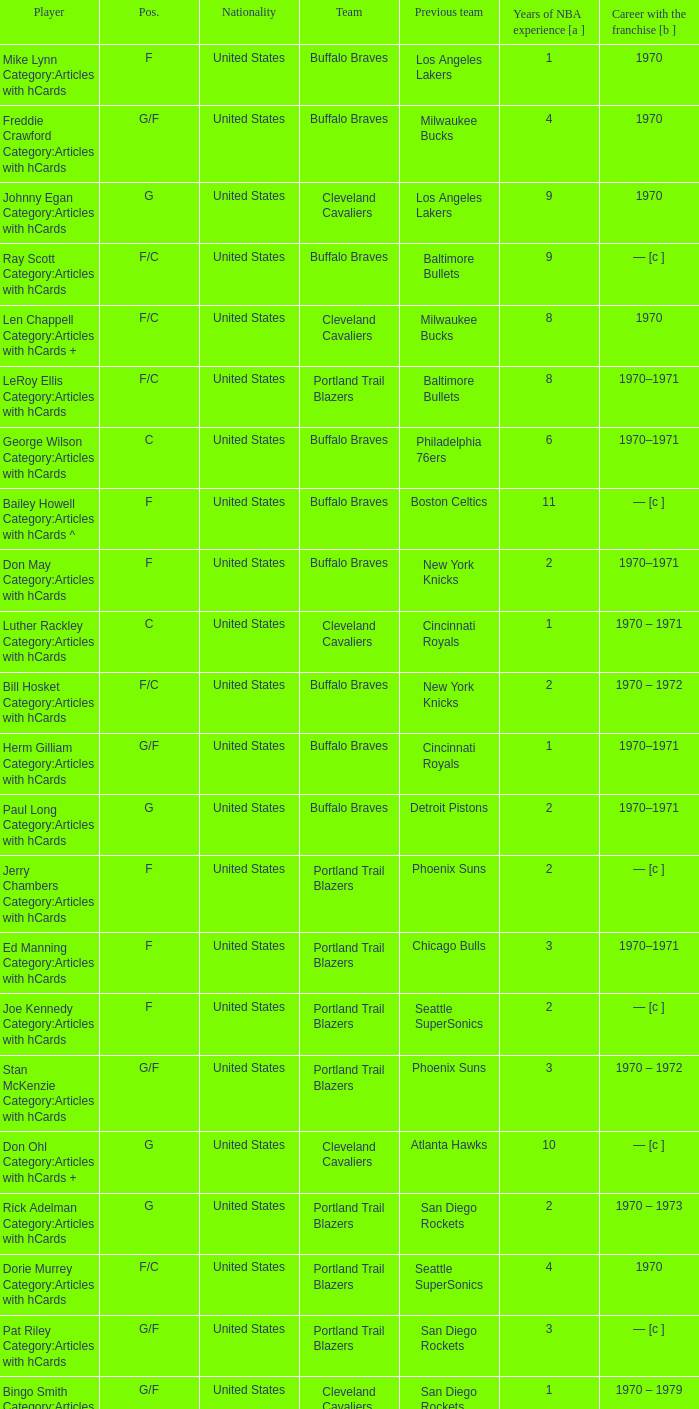How many years of NBA experience does the player who plays position g for the Portland Trail Blazers? 2.0. 